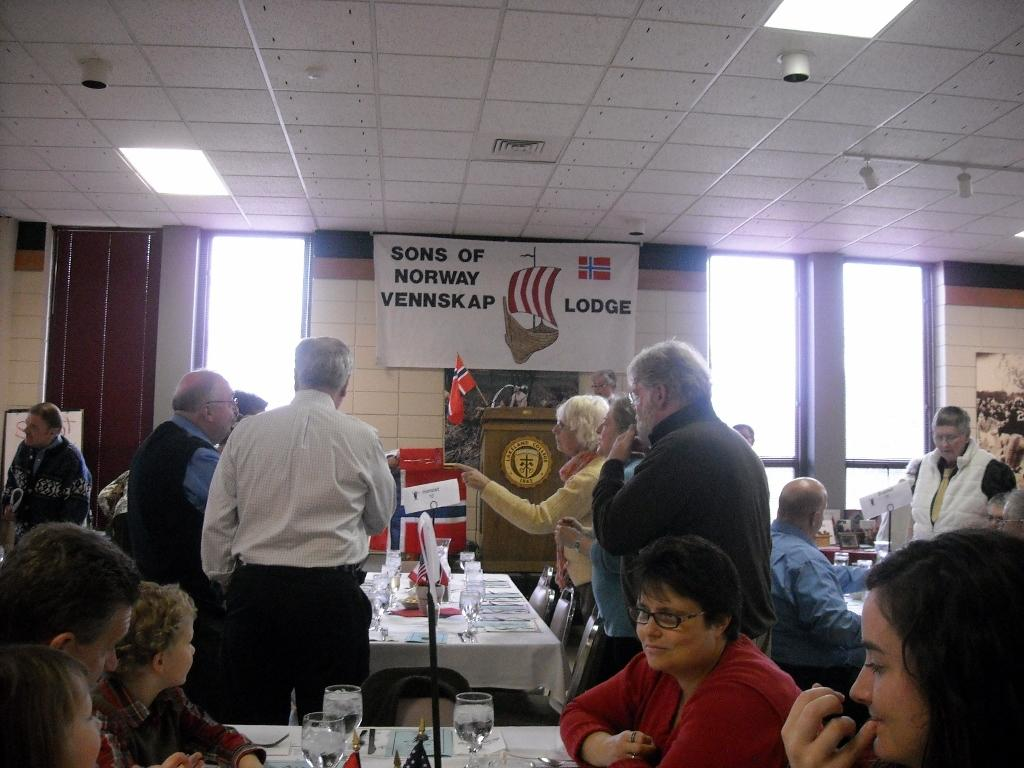What are the people in the image doing? There are people standing and sitting in the image. What type of furniture is present in the image? There are tables and chairs in the image. What objects can be seen on the tables? There are glasses on the tables in the image. What architectural feature is visible in the image? There are windows in the image. What type of slope can be seen in the image? There is no slope present in the image. What scale is used to measure the size of the people in the image? The image does not include any scale for measuring the size of the people; it only shows their relative sizes. 